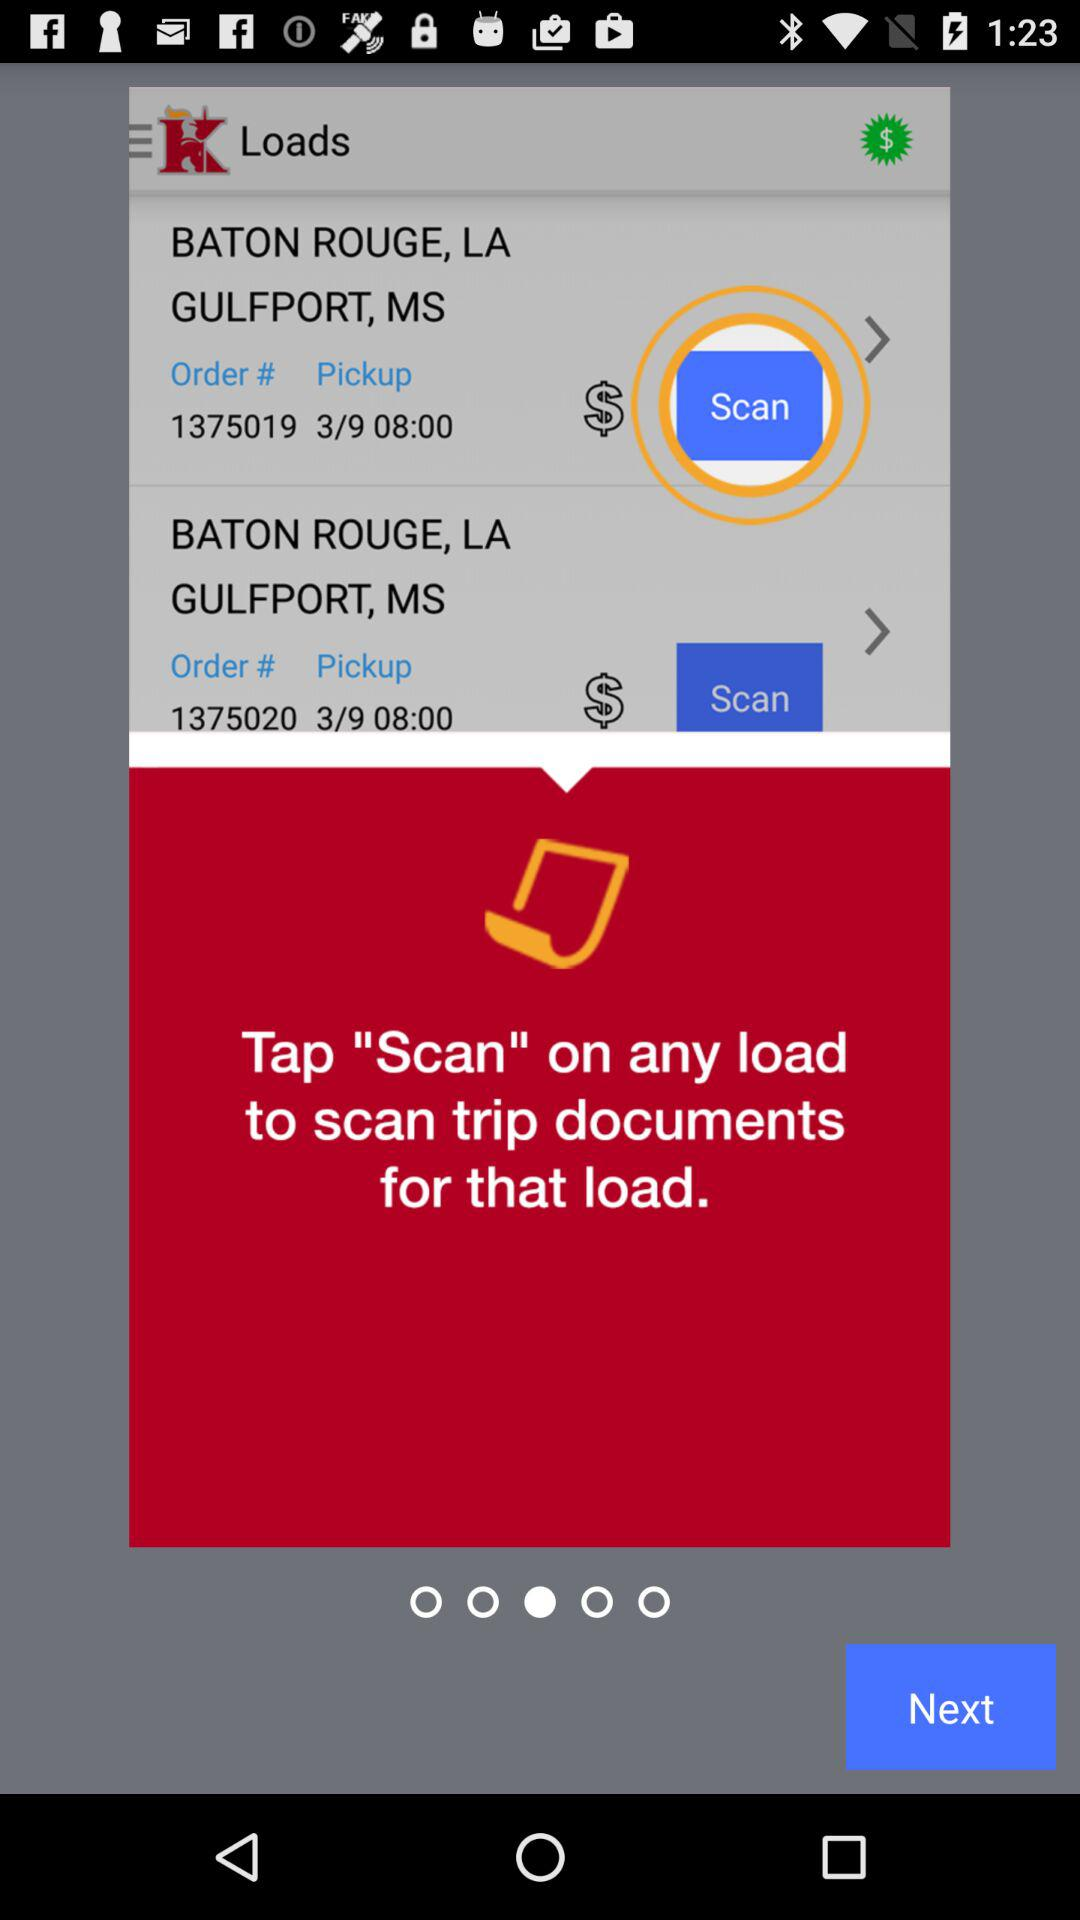How many loads are in this checkout?
Answer the question using a single word or phrase. 2 